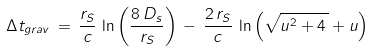<formula> <loc_0><loc_0><loc_500><loc_500>\Delta t _ { g r a v } \, = \, \frac { r _ { S } } { c } \, \ln \left ( \frac { 8 \, D _ { s } } { r _ { S } } \right ) \, - \, \frac { 2 \, r _ { S } } { c } \, \ln \left ( \sqrt { u ^ { 2 } + 4 \, } + u \right )</formula> 